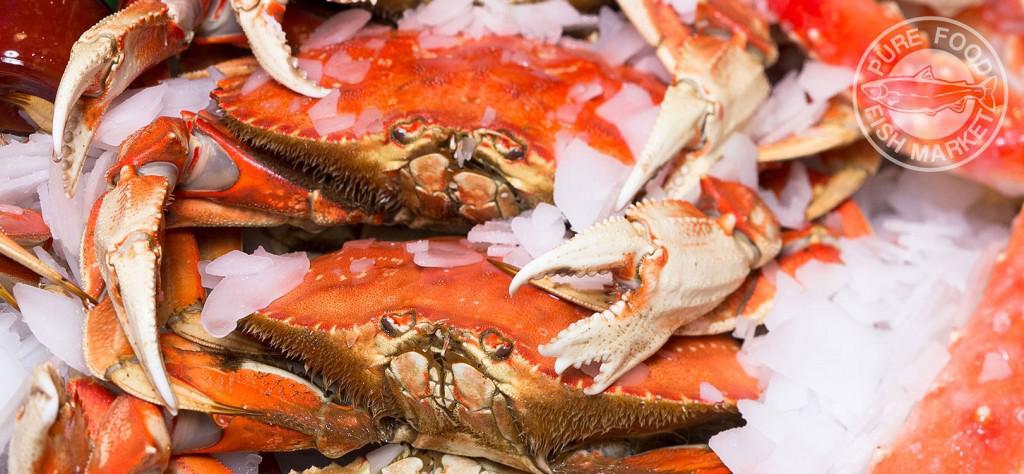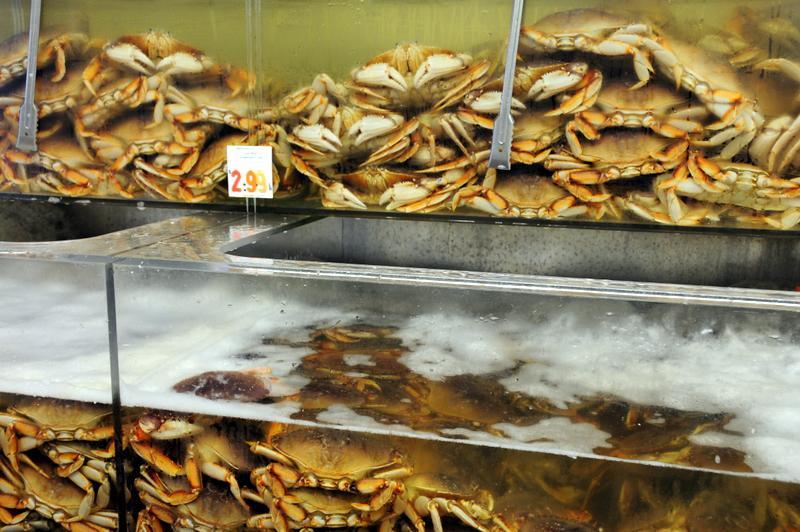The first image is the image on the left, the second image is the image on the right. Examine the images to the left and right. Is the description "A meal of crabs sits near an alcoholic beverage in one of the images." accurate? Answer yes or no. No. 